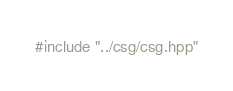<code> <loc_0><loc_0><loc_500><loc_500><_C++_>#include "../csg/csg.hpp"
</code> 